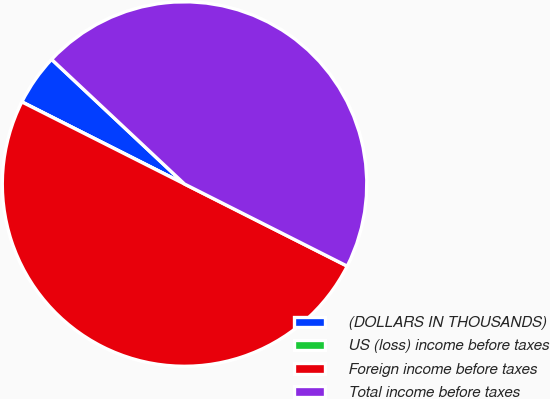Convert chart. <chart><loc_0><loc_0><loc_500><loc_500><pie_chart><fcel>(DOLLARS IN THOUSANDS)<fcel>US (loss) income before taxes<fcel>Foreign income before taxes<fcel>Total income before taxes<nl><fcel>4.55%<fcel>0.0%<fcel>50.0%<fcel>45.45%<nl></chart> 